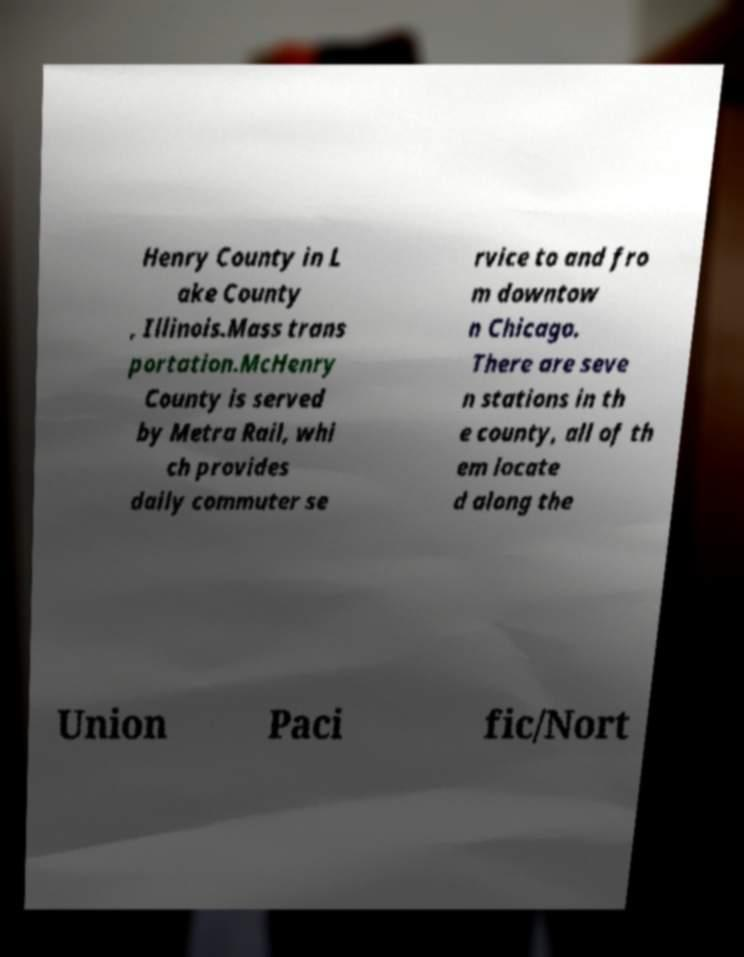Please read and relay the text visible in this image. What does it say? Henry County in L ake County , Illinois.Mass trans portation.McHenry County is served by Metra Rail, whi ch provides daily commuter se rvice to and fro m downtow n Chicago. There are seve n stations in th e county, all of th em locate d along the Union Paci fic/Nort 